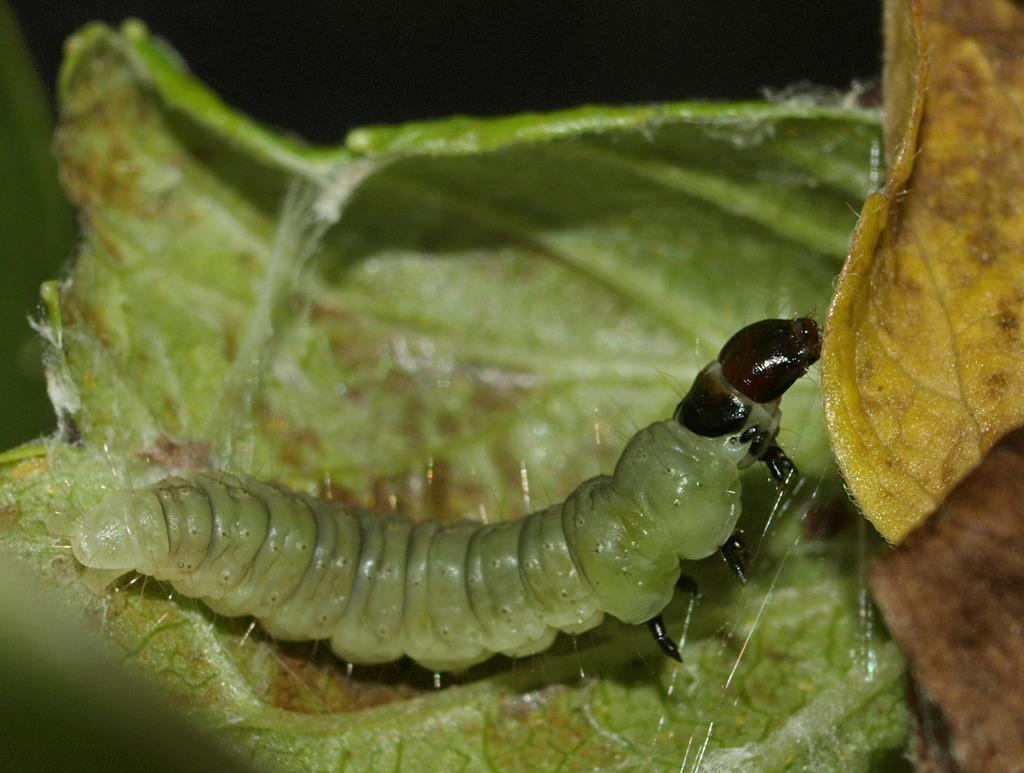What type of vegetation can be seen in the image? There are leaves in the image. Is there any animal life present in the image? Yes, there is a caterpillar on a leaf in the image. What type of juice is the caterpillar drinking in the image? There is no juice present in the image; the caterpillar is on a leaf. 